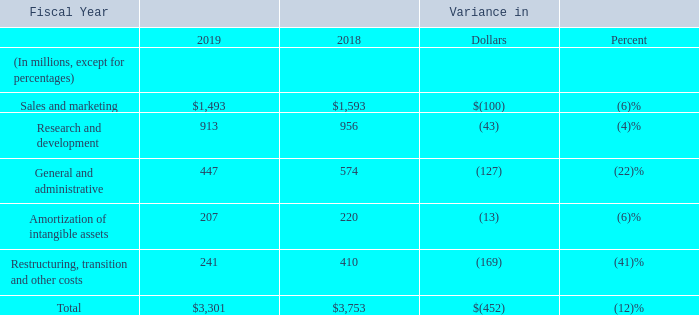Operating expenses
Sales and marketing expense decreased primarily due to a $51 million decrease in stock-based compensation expense and a $41 million decrease as a result of the divestiture of our WSS and PKI solutions.
Research and development expense decreased primarily due to a $66 million decrease in stockbased compensation expense.
General and administrative expense decreased primarily due to a $130 million decrease in stock-based compensation expense.
Amortization of intangible assets decreased primarily due to the intangible assets sold with the divestiture of WSS and PKI solutions.
Restructuring, transition and other costs reflect a decrease of $70 million in fiscal 2019 compared to fiscal 2018 in severance and other restructuring costs. In addition, fiscal 2018 costs included $88 million of transition related costs related to our fiscal 2018 divestiture of our WSS and PKI solutions compared to $3 million in fiscal 2019.
Why did Amortization of intangible assets decrease primarily due to? Intangible assets sold with the divestiture of wss and pki solutions. What is the decrease in  Sales and marketing from Fiscal year 2018 to 2019?
Answer scale should be: million. 100. What is the decrease in  Research and development  from Fiscal year 2018 to 2019?
Answer scale should be: million. 43. What is the total operating expense of fiscal years 2018 and 2019?
Answer scale should be: million. 3,301+3,753
Answer: 7054. What is the total impact on the decrease in Sales and marketing expense from stock-based compensation expense and divestiture of our WSS and PKI solutions?
Answer scale should be: million. 51+41
Answer: 92. What is the average Sales and marketing expenses for fiscal years 2019 and 2018? 
Answer scale should be: million. (1,493+1,593)/2
Answer: 1543. 